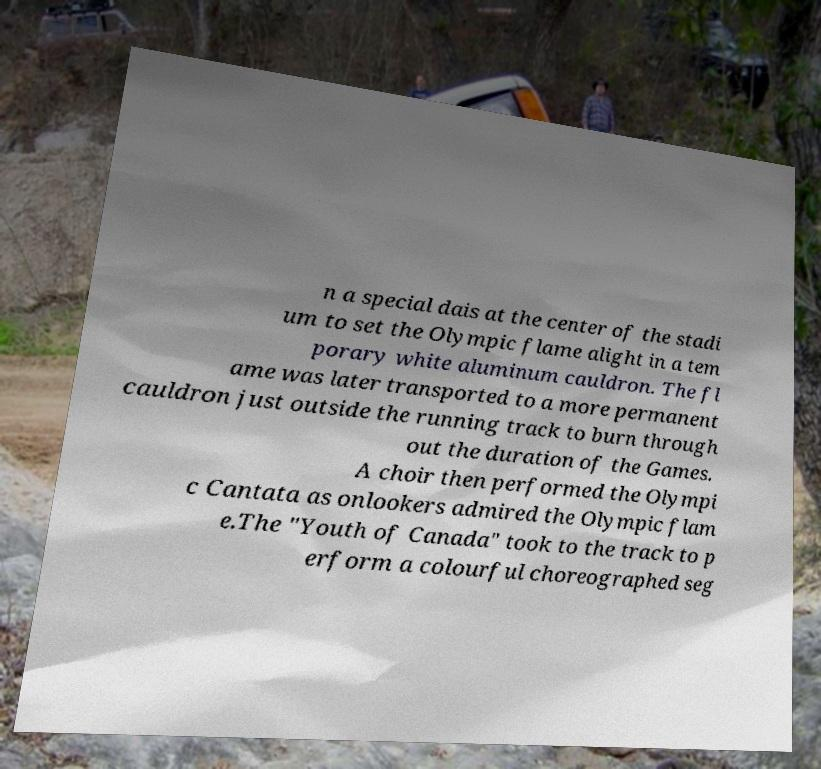Could you extract and type out the text from this image? n a special dais at the center of the stadi um to set the Olympic flame alight in a tem porary white aluminum cauldron. The fl ame was later transported to a more permanent cauldron just outside the running track to burn through out the duration of the Games. A choir then performed the Olympi c Cantata as onlookers admired the Olympic flam e.The "Youth of Canada" took to the track to p erform a colourful choreographed seg 